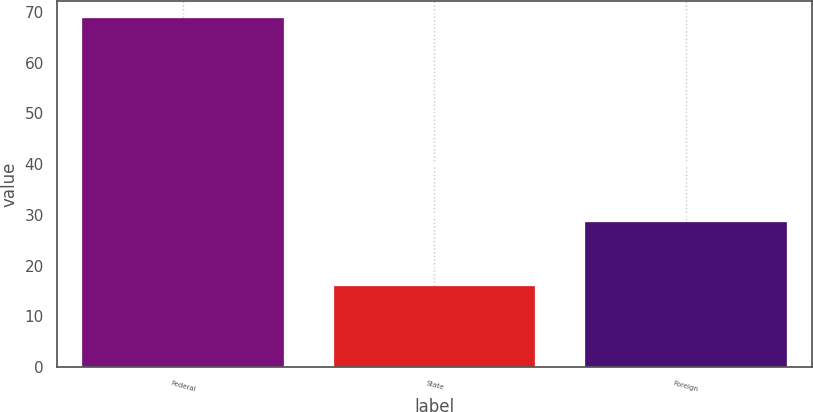Convert chart to OTSL. <chart><loc_0><loc_0><loc_500><loc_500><bar_chart><fcel>Federal<fcel>State<fcel>Foreign<nl><fcel>68.8<fcel>15.9<fcel>28.6<nl></chart> 